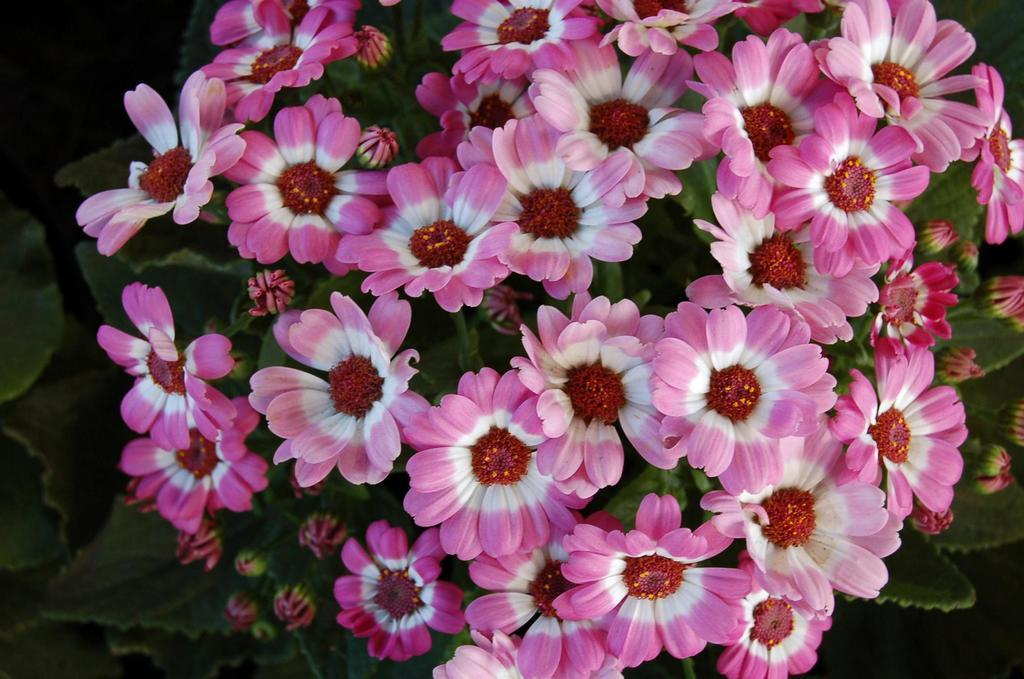What type of plants are visible in the image? There are plants with flowers in the image. What stage of growth are the plants in? The plants have buds. What can be observed about the background of the image? The background of the image is dark. Can you see any beds or cribs in the image? No, there are no beds or cribs present in the image. How far is the ocean from the plants in the image? There is no ocean visible in the image, so it is not possible to determine its distance from the plants. 